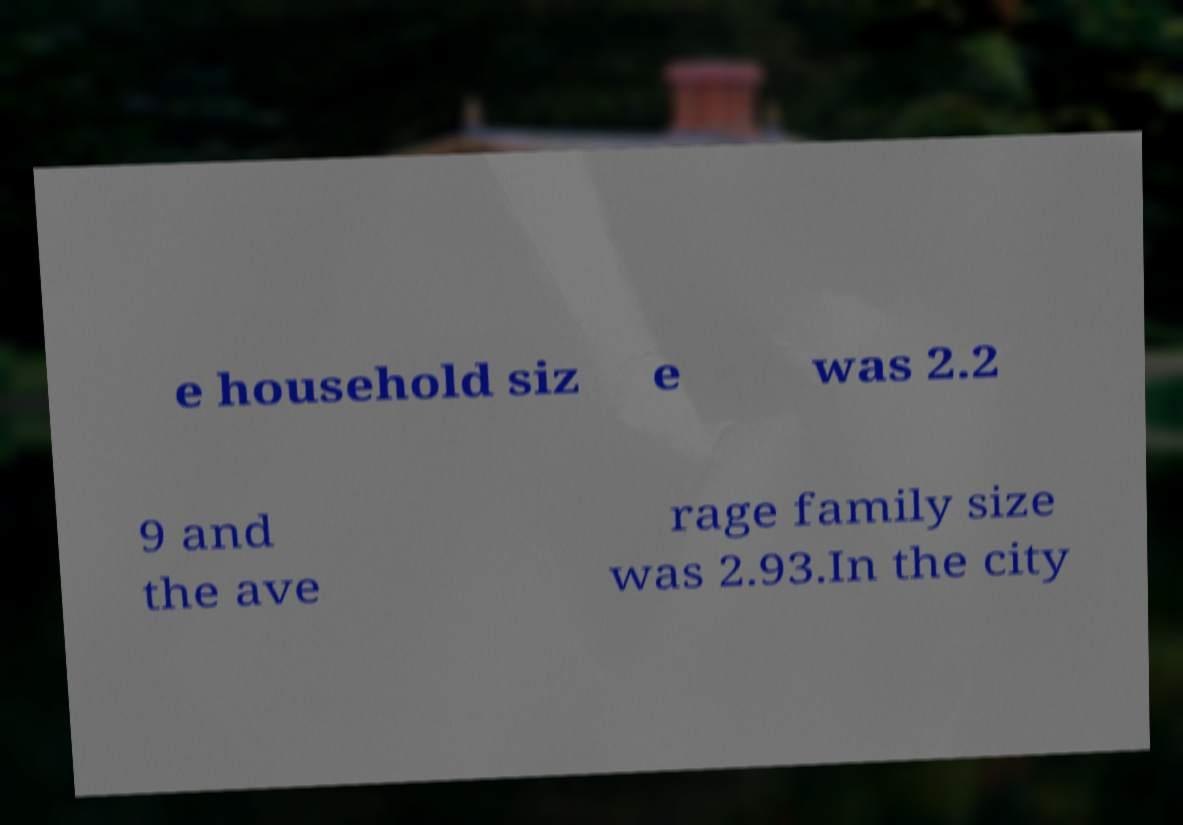What messages or text are displayed in this image? I need them in a readable, typed format. e household siz e was 2.2 9 and the ave rage family size was 2.93.In the city 